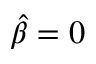<formula> <loc_0><loc_0><loc_500><loc_500>\hat { \beta } = 0</formula> 